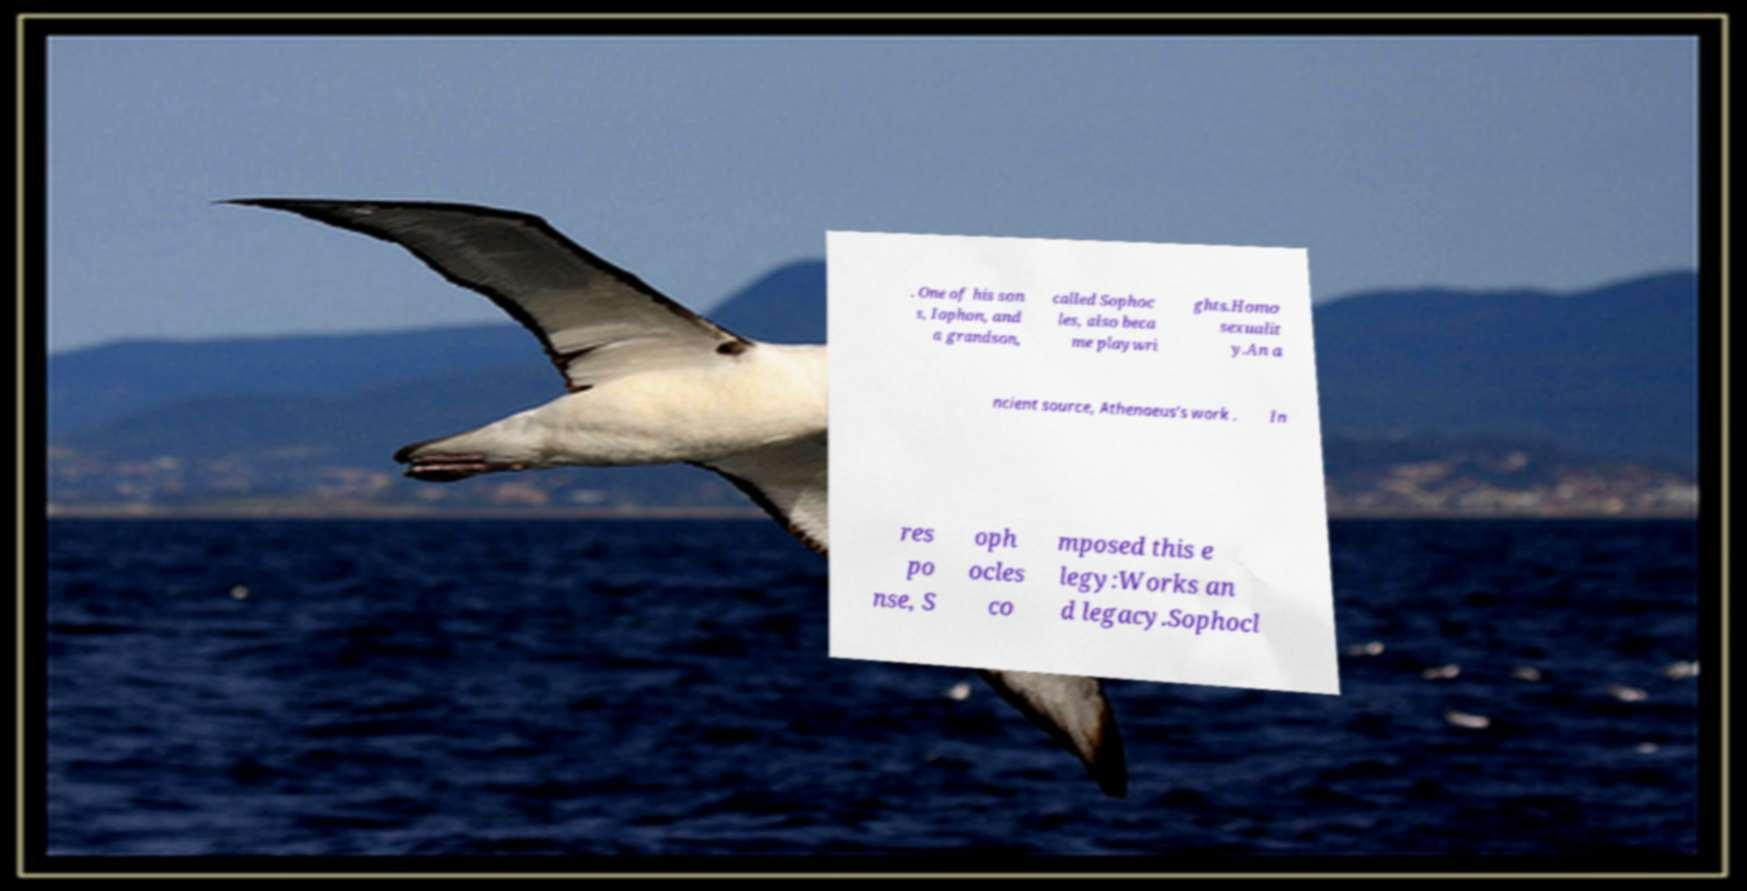There's text embedded in this image that I need extracted. Can you transcribe it verbatim? . One of his son s, Iophon, and a grandson, called Sophoc les, also beca me playwri ghts.Homo sexualit y.An a ncient source, Athenaeus’s work . In res po nse, S oph ocles co mposed this e legy:Works an d legacy.Sophocl 